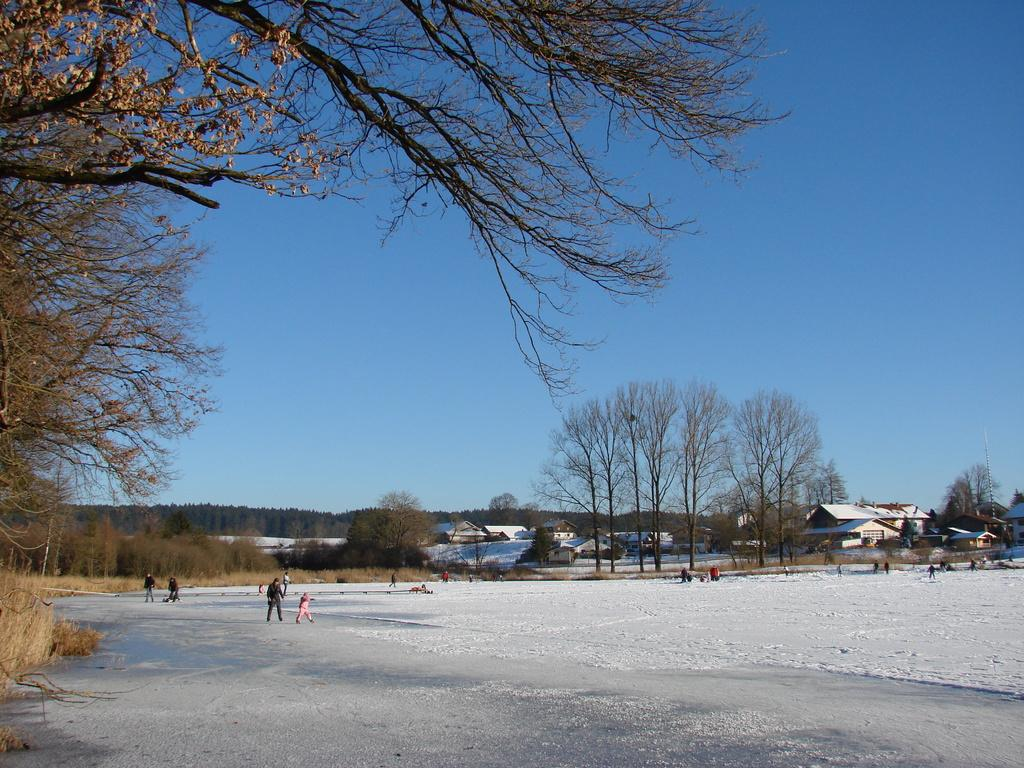What are the people in the image doing? The group of people is standing on the ground in the image. What type of structures can be seen in the image? There are houses with roofs in the image. What type of vegetation is present in the image? There is a group of trees and plants in the image. What is visible in the sky in the image? The sky appears cloudy in the image. What type of cheese is being used to answer questions about the image? There is no cheese present in the image, and cheese is not used to answer questions about the image. 